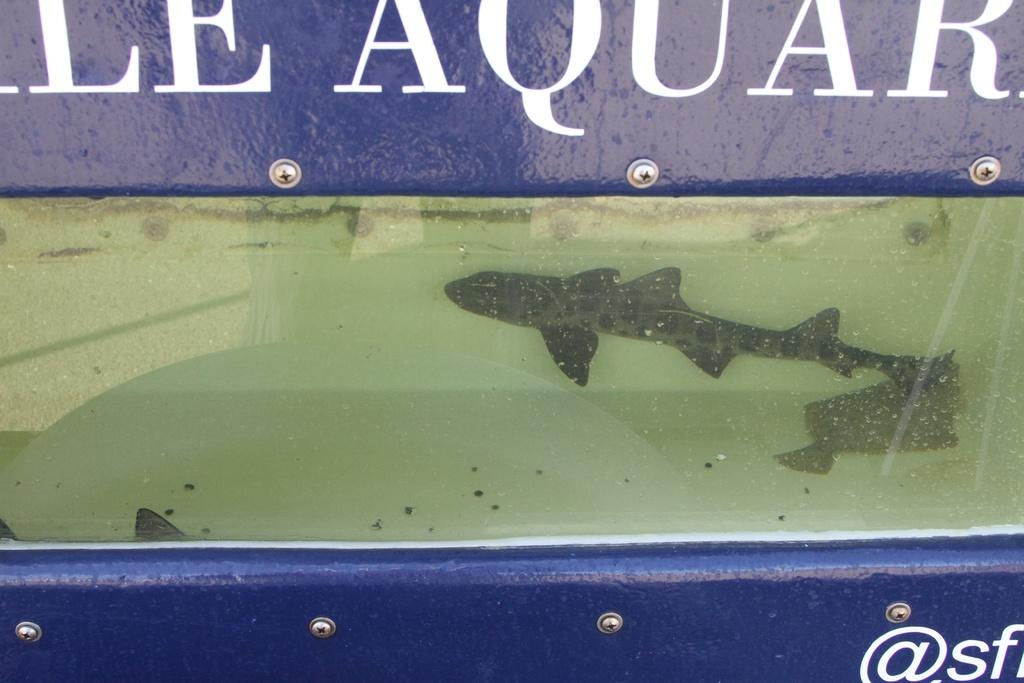What type of animals can be seen in the water in the image? There are two fishes in the water in the image. What objects can be seen with screws in the image? There are boards with screws in the image. How many cars can be seen in the image? There are no cars present in the image. What type of sticks are used for bathing in the image? There is no bath or sticks for bathing present in the image. 